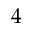Convert formula to latex. <formula><loc_0><loc_0><loc_500><loc_500>4</formula> 